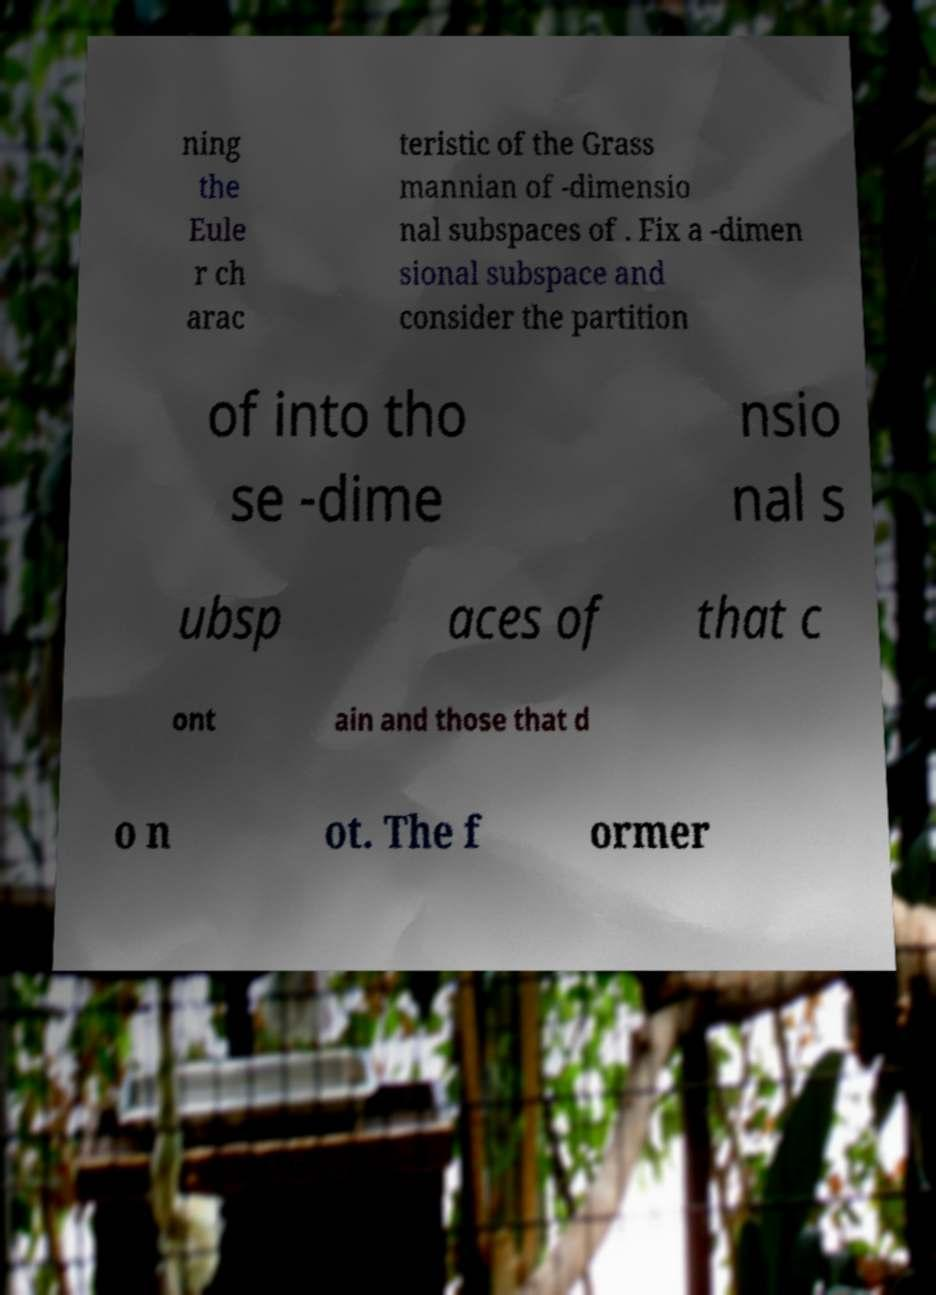I need the written content from this picture converted into text. Can you do that? ning the Eule r ch arac teristic of the Grass mannian of -dimensio nal subspaces of . Fix a -dimen sional subspace and consider the partition of into tho se -dime nsio nal s ubsp aces of that c ont ain and those that d o n ot. The f ormer 